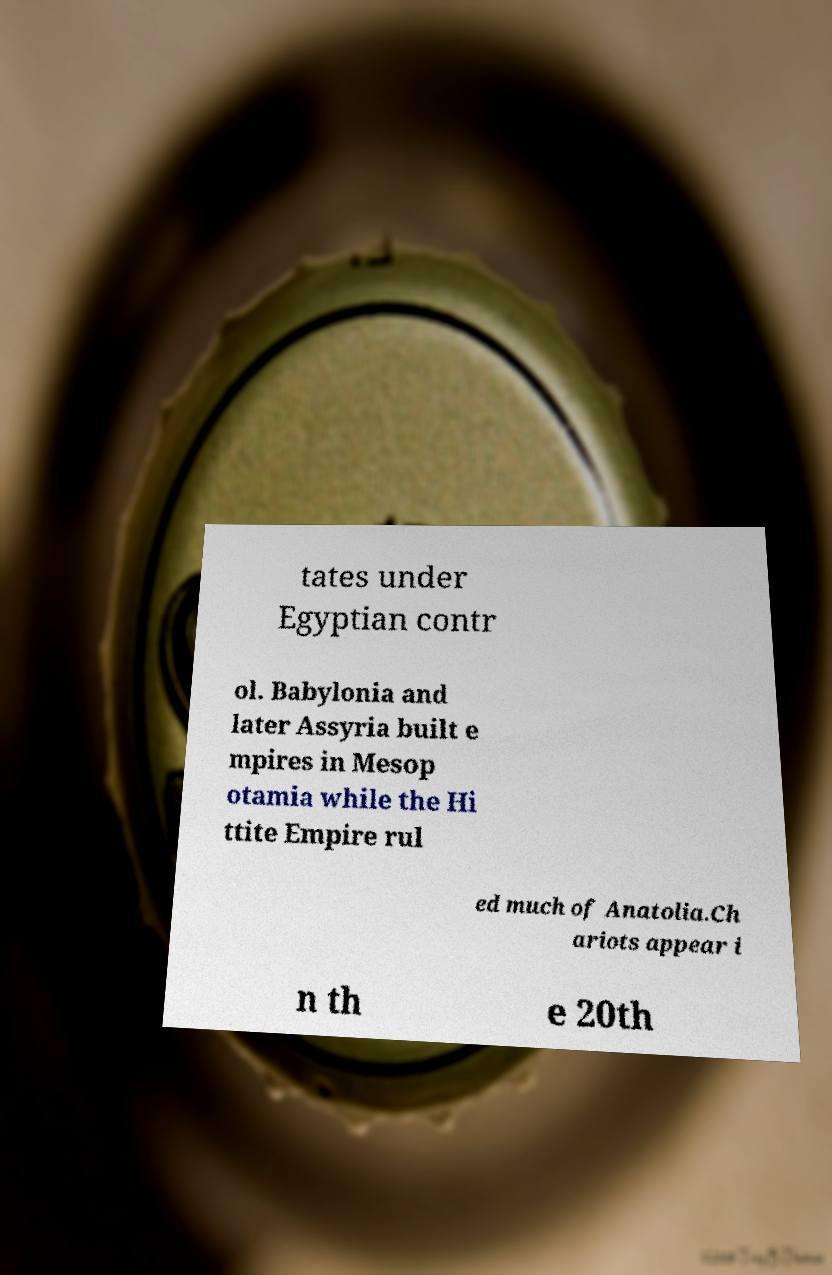What messages or text are displayed in this image? I need them in a readable, typed format. tates under Egyptian contr ol. Babylonia and later Assyria built e mpires in Mesop otamia while the Hi ttite Empire rul ed much of Anatolia.Ch ariots appear i n th e 20th 